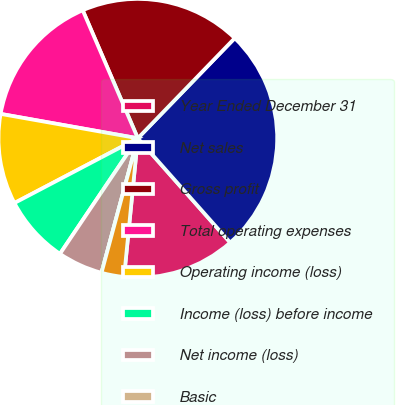Convert chart to OTSL. <chart><loc_0><loc_0><loc_500><loc_500><pie_chart><fcel>Year Ended December 31<fcel>Net sales<fcel>Gross profit<fcel>Total operating expenses<fcel>Operating income (loss)<fcel>Income (loss) before income<fcel>Net income (loss)<fcel>Basic<fcel>Assuming dilution<nl><fcel>13.11%<fcel>26.22%<fcel>18.71%<fcel>15.73%<fcel>10.49%<fcel>7.87%<fcel>5.24%<fcel>0.0%<fcel>2.62%<nl></chart> 